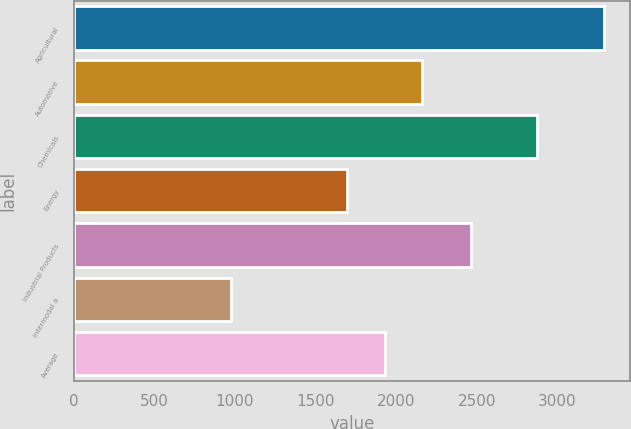Convert chart. <chart><loc_0><loc_0><loc_500><loc_500><bar_chart><fcel>Agricultural<fcel>Automotive<fcel>Chemicals<fcel>Energy<fcel>Industrial Products<fcel>Intermodal a<fcel>Average<nl><fcel>3286<fcel>2159.4<fcel>2874<fcel>1697<fcel>2461<fcel>974<fcel>1928.2<nl></chart> 